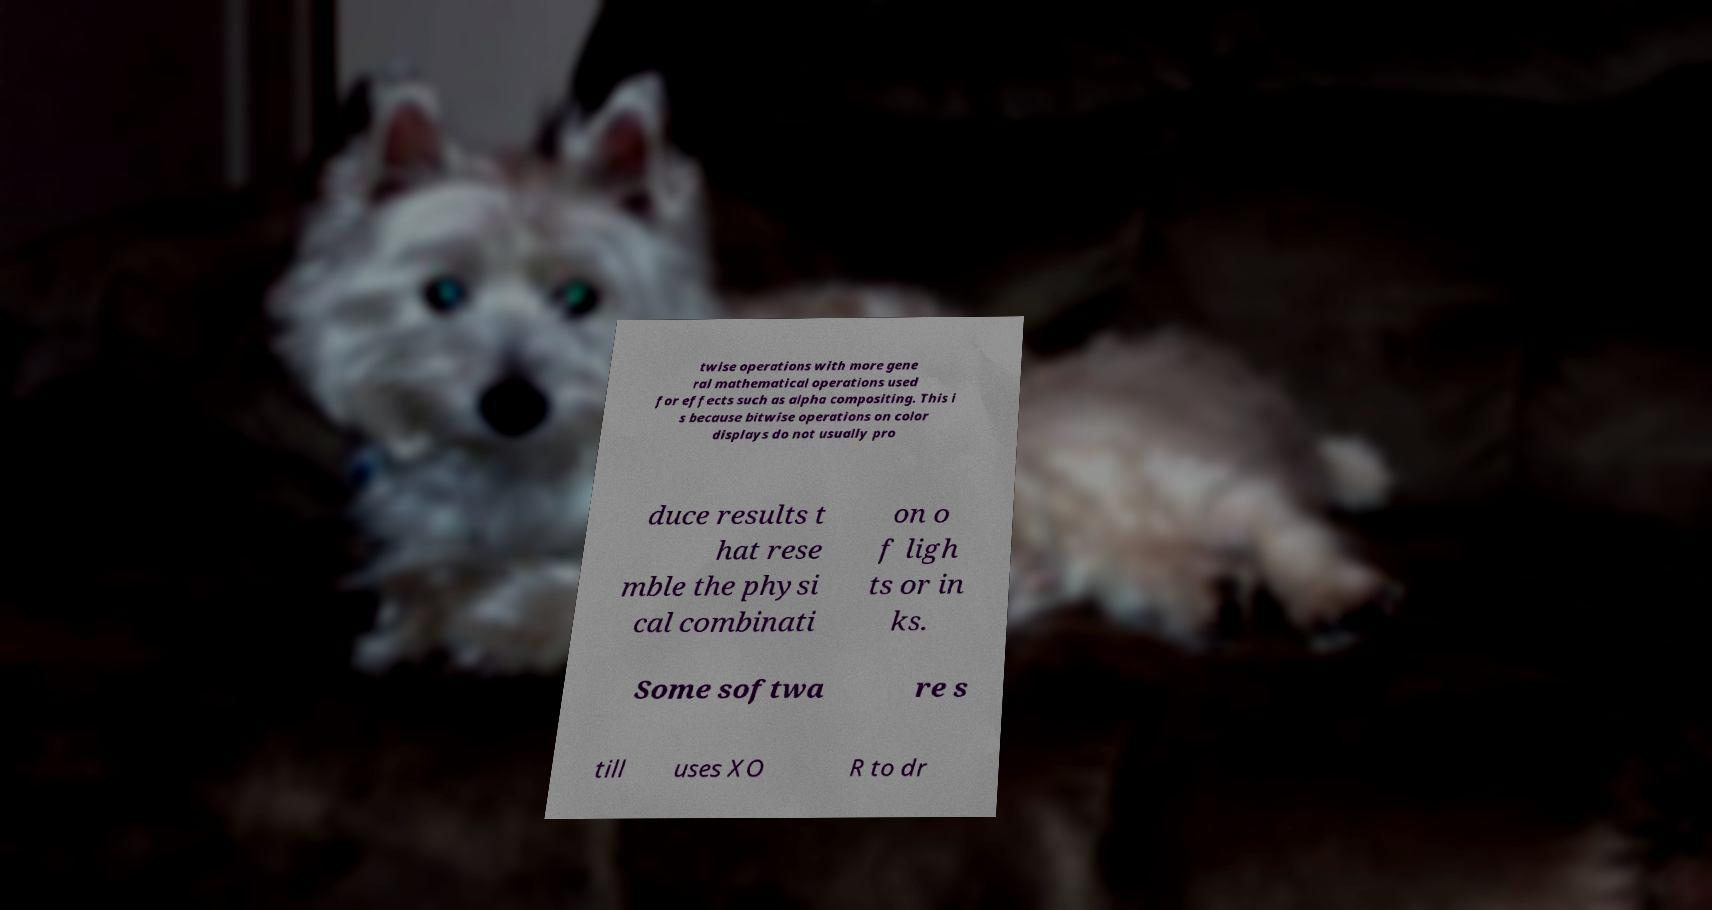What messages or text are displayed in this image? I need them in a readable, typed format. twise operations with more gene ral mathematical operations used for effects such as alpha compositing. This i s because bitwise operations on color displays do not usually pro duce results t hat rese mble the physi cal combinati on o f ligh ts or in ks. Some softwa re s till uses XO R to dr 